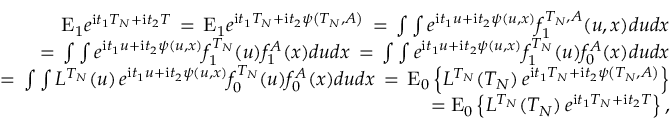<formula> <loc_0><loc_0><loc_500><loc_500>\begin{array} { r l r } & { E _ { 1 } e ^ { i t _ { 1 } T _ { N } + i t _ { 2 } T } \, = \, E _ { 1 } e ^ { i t _ { 1 } T _ { N } + i t _ { 2 } \psi \left ( T _ { N } , A \right ) } \, = \, \int \int e ^ { i t _ { 1 } u + i t _ { 2 } \psi \left ( u , x \right ) } f _ { 1 } ^ { T _ { N } , A } ( u , x ) d u d x } \\ & { \quad = \, \int \int e ^ { i t _ { 1 } u + i t _ { 2 } \psi \left ( u , x \right ) } f _ { 1 } ^ { T _ { N } } ( u ) f _ { 1 } ^ { A } ( x ) d u d x \, = \, \int \int e ^ { i t _ { 1 } u + i t _ { 2 } \psi \left ( u , x \right ) } f _ { 1 } ^ { T _ { N } } ( u ) f _ { 0 } ^ { A } ( x ) d u d x } \\ & { \quad = \, \int \int L ^ { T _ { N } } ( u ) \, e ^ { i t _ { 1 } u + i t _ { 2 } \psi \left ( u , x \right ) } f _ { 0 } ^ { T _ { N } } ( u ) f _ { 0 } ^ { A } ( x ) d u d x \, = \, E _ { 0 } \left \{ L ^ { T _ { N } } ( T _ { N } ) \, e ^ { i t _ { 1 } T _ { N } + i t _ { 2 } \psi \left ( T _ { N } , A \right ) } \right \} } \\ & { = E _ { 0 } \left \{ L ^ { T _ { N } } ( T _ { N } ) \, e ^ { i t _ { 1 } T _ { N } + i t _ { 2 } T } \right \} , } \end{array}</formula> 